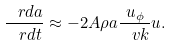Convert formula to latex. <formula><loc_0><loc_0><loc_500><loc_500>\frac { \ r d a } { \ r d t } \approx - 2 A \rho a \frac { u _ { \phi } } { \ v k } u .</formula> 